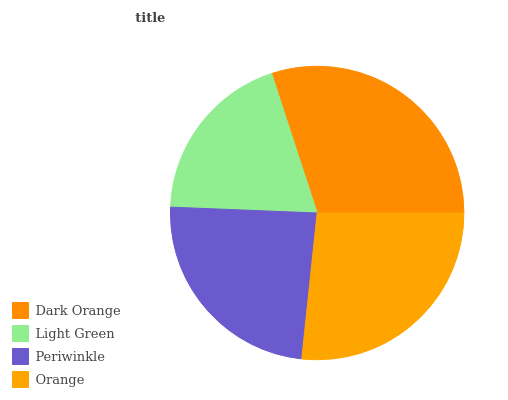Is Light Green the minimum?
Answer yes or no. Yes. Is Dark Orange the maximum?
Answer yes or no. Yes. Is Periwinkle the minimum?
Answer yes or no. No. Is Periwinkle the maximum?
Answer yes or no. No. Is Periwinkle greater than Light Green?
Answer yes or no. Yes. Is Light Green less than Periwinkle?
Answer yes or no. Yes. Is Light Green greater than Periwinkle?
Answer yes or no. No. Is Periwinkle less than Light Green?
Answer yes or no. No. Is Orange the high median?
Answer yes or no. Yes. Is Periwinkle the low median?
Answer yes or no. Yes. Is Light Green the high median?
Answer yes or no. No. Is Orange the low median?
Answer yes or no. No. 